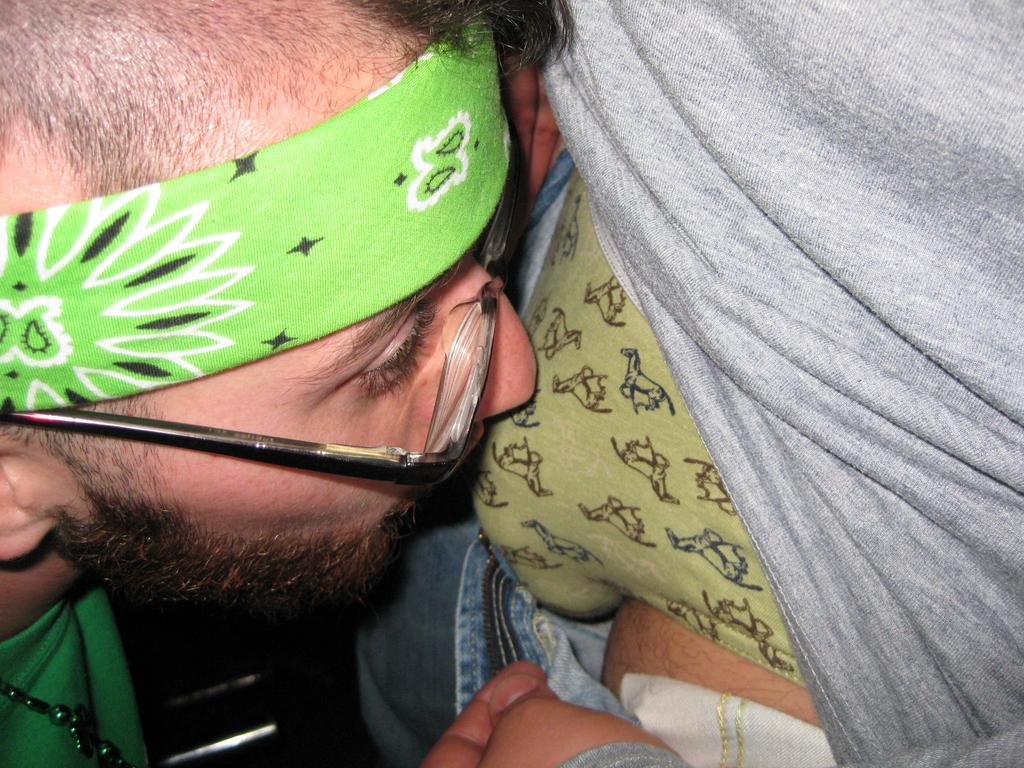What can be seen in the image? There is a person in the image. Can you describe the person's appearance? The person is wearing a headband and spectacles. What is the person holding in their hand? The person is holding a cloth in their hand. What type of boundary can be seen in the image? There is no boundary present in the image; it features a person wearing a headband, spectacles, and holding a cloth. Can you tell me what kind of pan the person is using in the image? There is no pan present in the image. 